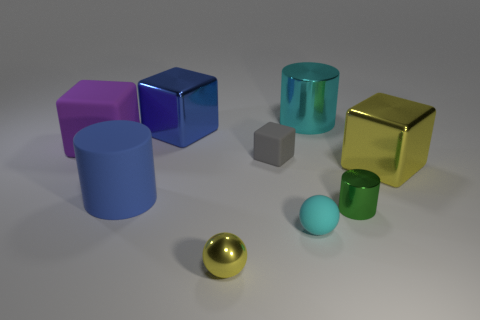Are there any other things of the same color as the large matte cube?
Offer a very short reply. No. What number of objects are either small red cylinders or small gray cubes?
Offer a terse response. 1. There is a rubber sphere; does it have the same size as the blue object behind the large purple cube?
Make the answer very short. No. How big is the rubber thing that is right of the small rubber thing that is behind the big metal object in front of the large purple rubber thing?
Offer a very short reply. Small. Is there a gray ball?
Keep it short and to the point. No. There is a small object that is the same color as the big shiny cylinder; what material is it?
Your response must be concise. Rubber. How many large shiny blocks have the same color as the shiny sphere?
Ensure brevity in your answer.  1. What number of objects are balls in front of the rubber ball or things that are to the right of the blue matte cylinder?
Your answer should be compact. 7. What number of cylinders are in front of the large shiny block in front of the small cube?
Offer a terse response. 2. There is a small ball that is the same material as the green object; what is its color?
Make the answer very short. Yellow. 